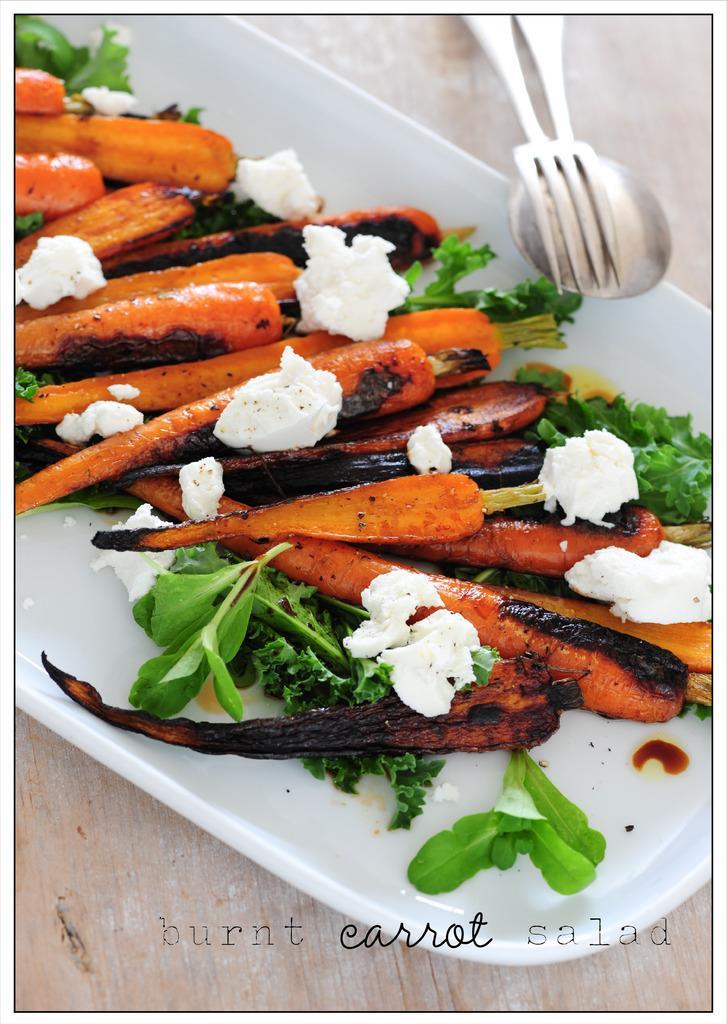Could you give a brief overview of what you see in this image? In this picture we can see tray with carrots and food items, spoon and fork on the wooden platform. At the bottom of the image we can see text. 